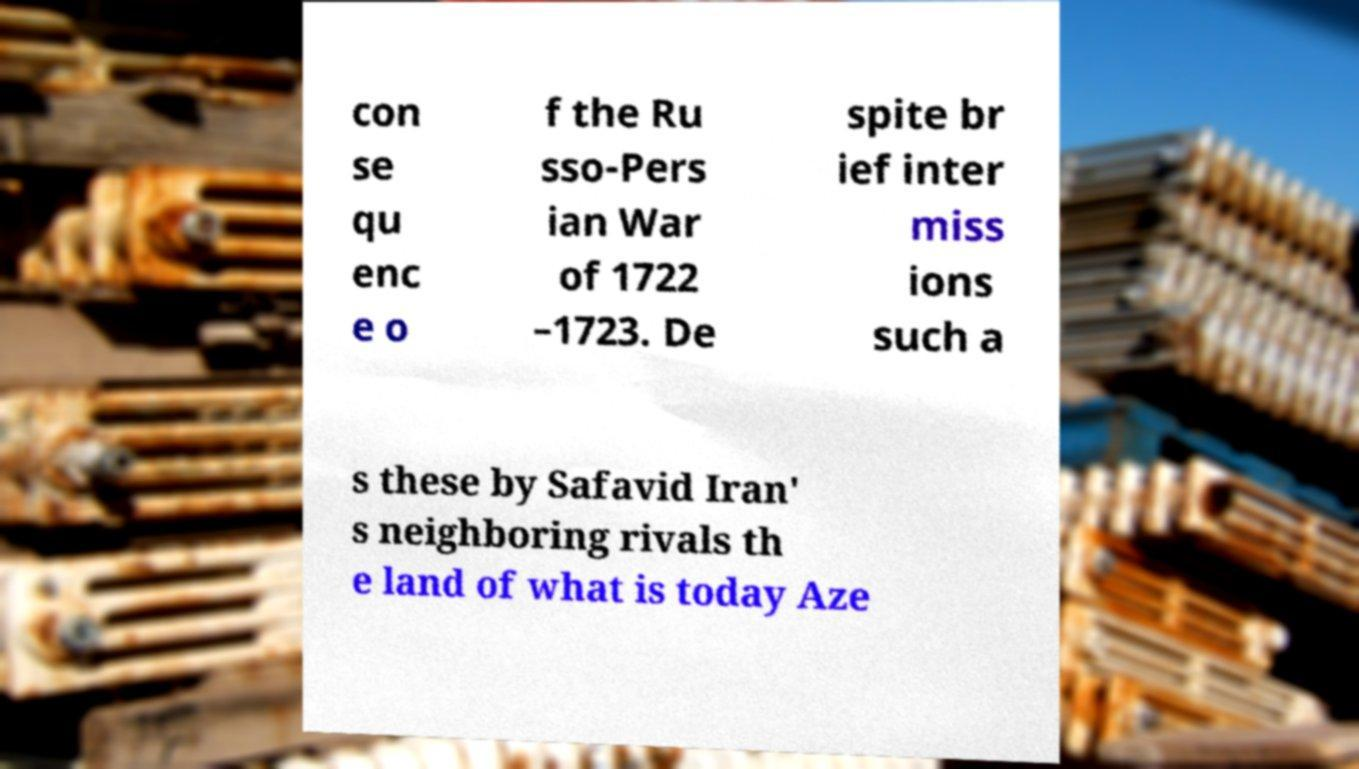For documentation purposes, I need the text within this image transcribed. Could you provide that? con se qu enc e o f the Ru sso-Pers ian War of 1722 –1723. De spite br ief inter miss ions such a s these by Safavid Iran' s neighboring rivals th e land of what is today Aze 